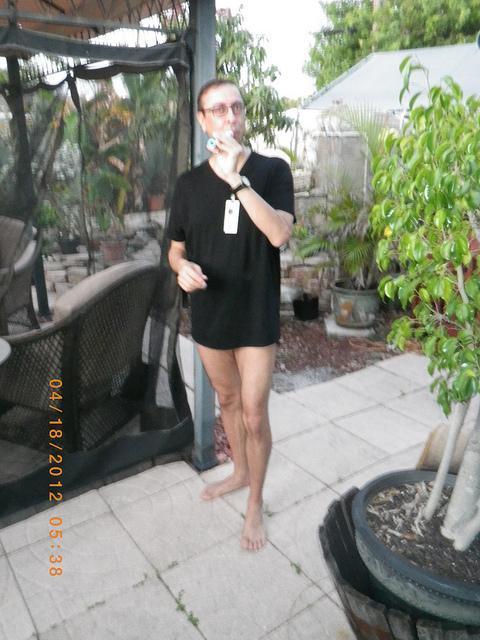How many chairs are there?
Give a very brief answer. 2. How many potted plants are there?
Give a very brief answer. 2. 